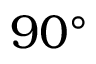Convert formula to latex. <formula><loc_0><loc_0><loc_500><loc_500>9 0 ^ { \circ }</formula> 